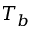Convert formula to latex. <formula><loc_0><loc_0><loc_500><loc_500>T _ { b }</formula> 